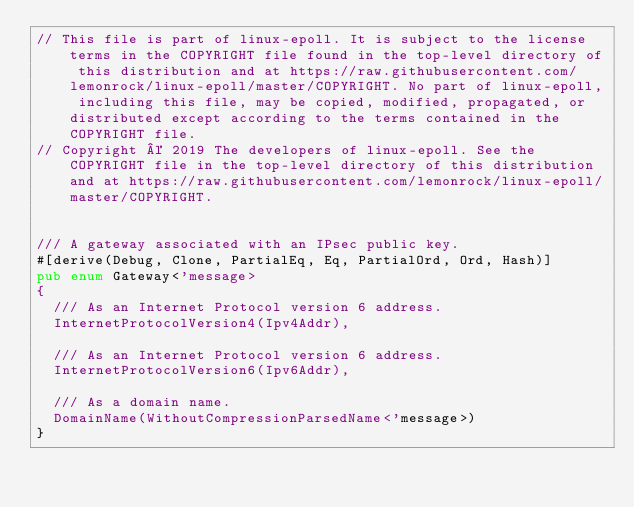<code> <loc_0><loc_0><loc_500><loc_500><_Rust_>// This file is part of linux-epoll. It is subject to the license terms in the COPYRIGHT file found in the top-level directory of this distribution and at https://raw.githubusercontent.com/lemonrock/linux-epoll/master/COPYRIGHT. No part of linux-epoll, including this file, may be copied, modified, propagated, or distributed except according to the terms contained in the COPYRIGHT file.
// Copyright © 2019 The developers of linux-epoll. See the COPYRIGHT file in the top-level directory of this distribution and at https://raw.githubusercontent.com/lemonrock/linux-epoll/master/COPYRIGHT.


/// A gateway associated with an IPsec public key.
#[derive(Debug, Clone, PartialEq, Eq, PartialOrd, Ord, Hash)]
pub enum Gateway<'message>
{
	/// As an Internet Protocol version 6 address.
	InternetProtocolVersion4(Ipv4Addr),

	/// As an Internet Protocol version 6 address.
	InternetProtocolVersion6(Ipv6Addr),

	/// As a domain name.
	DomainName(WithoutCompressionParsedName<'message>)
}
</code> 